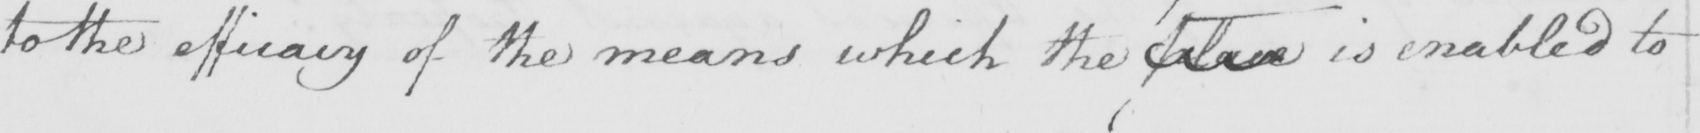Please provide the text content of this handwritten line. to the efficacy of the means which the place is enabled to 